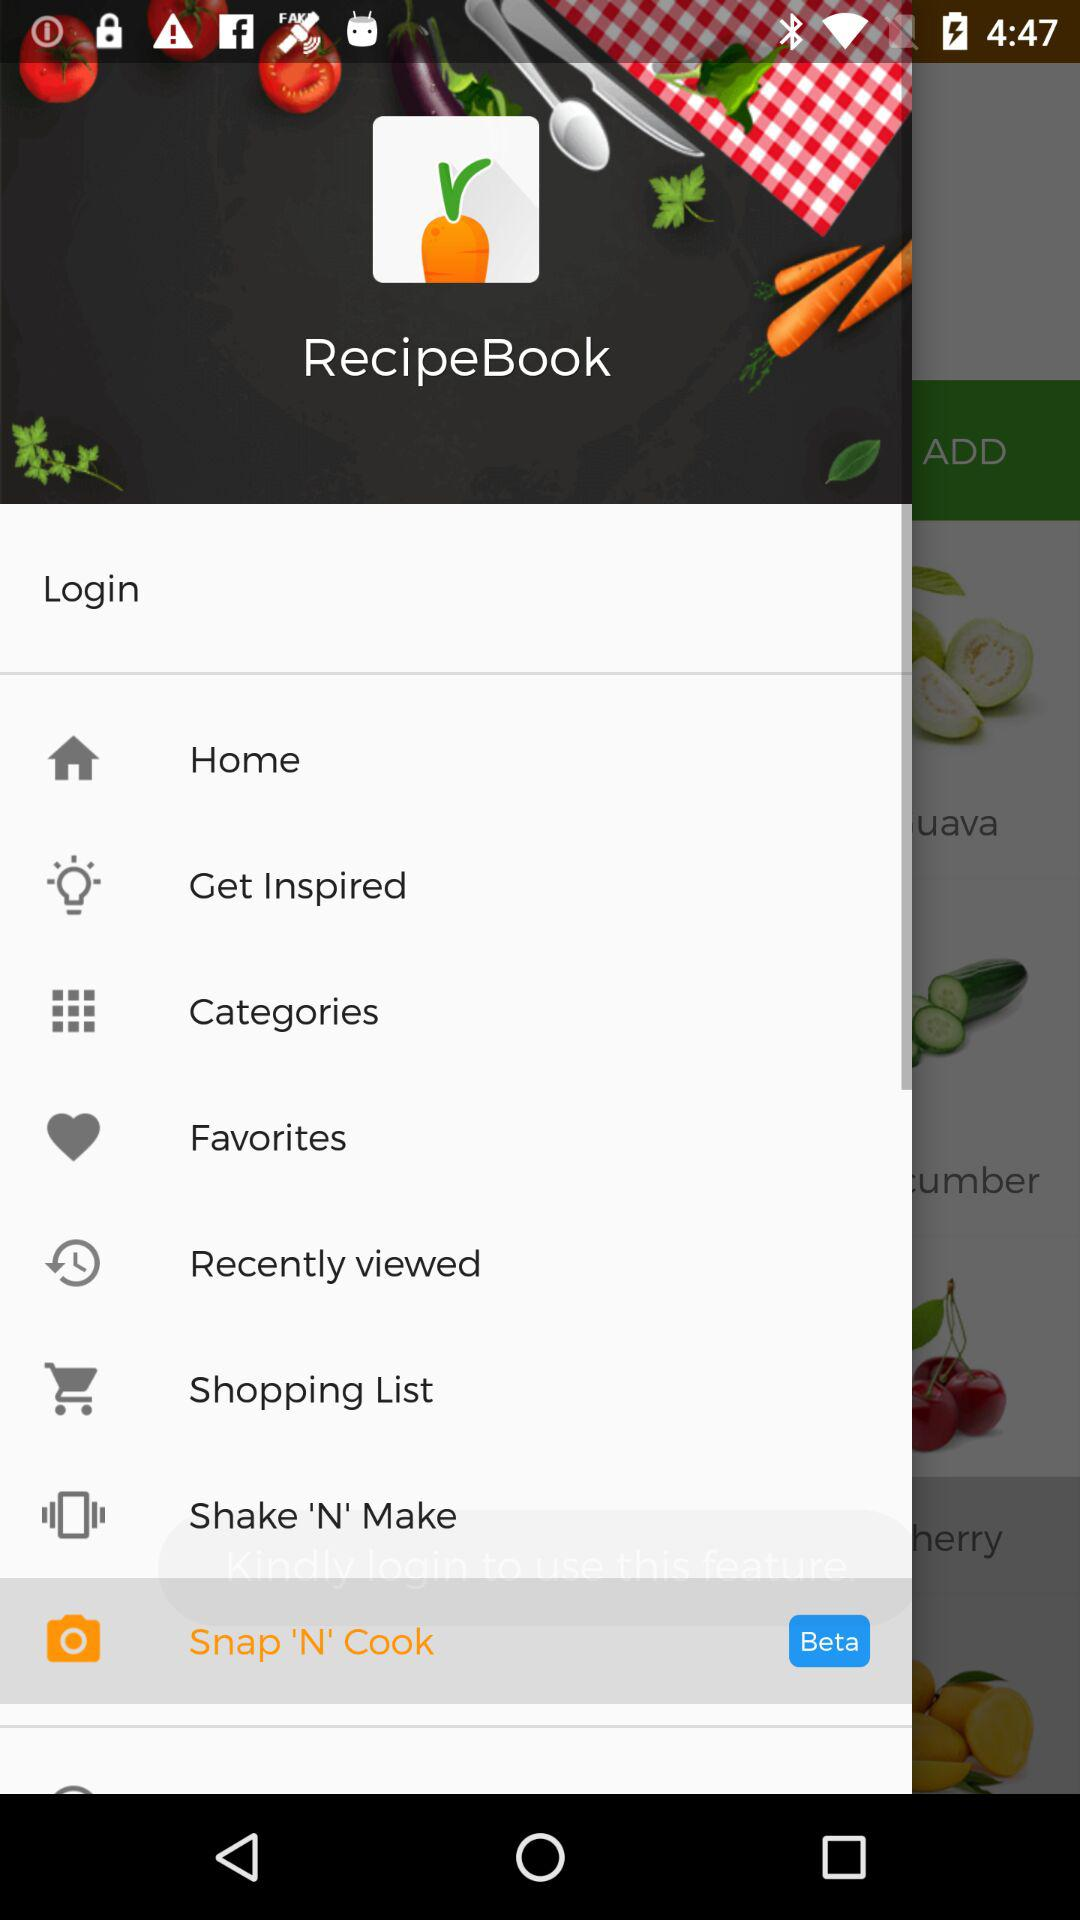What is the name of the application? The name of the application is "RecipeBook". 